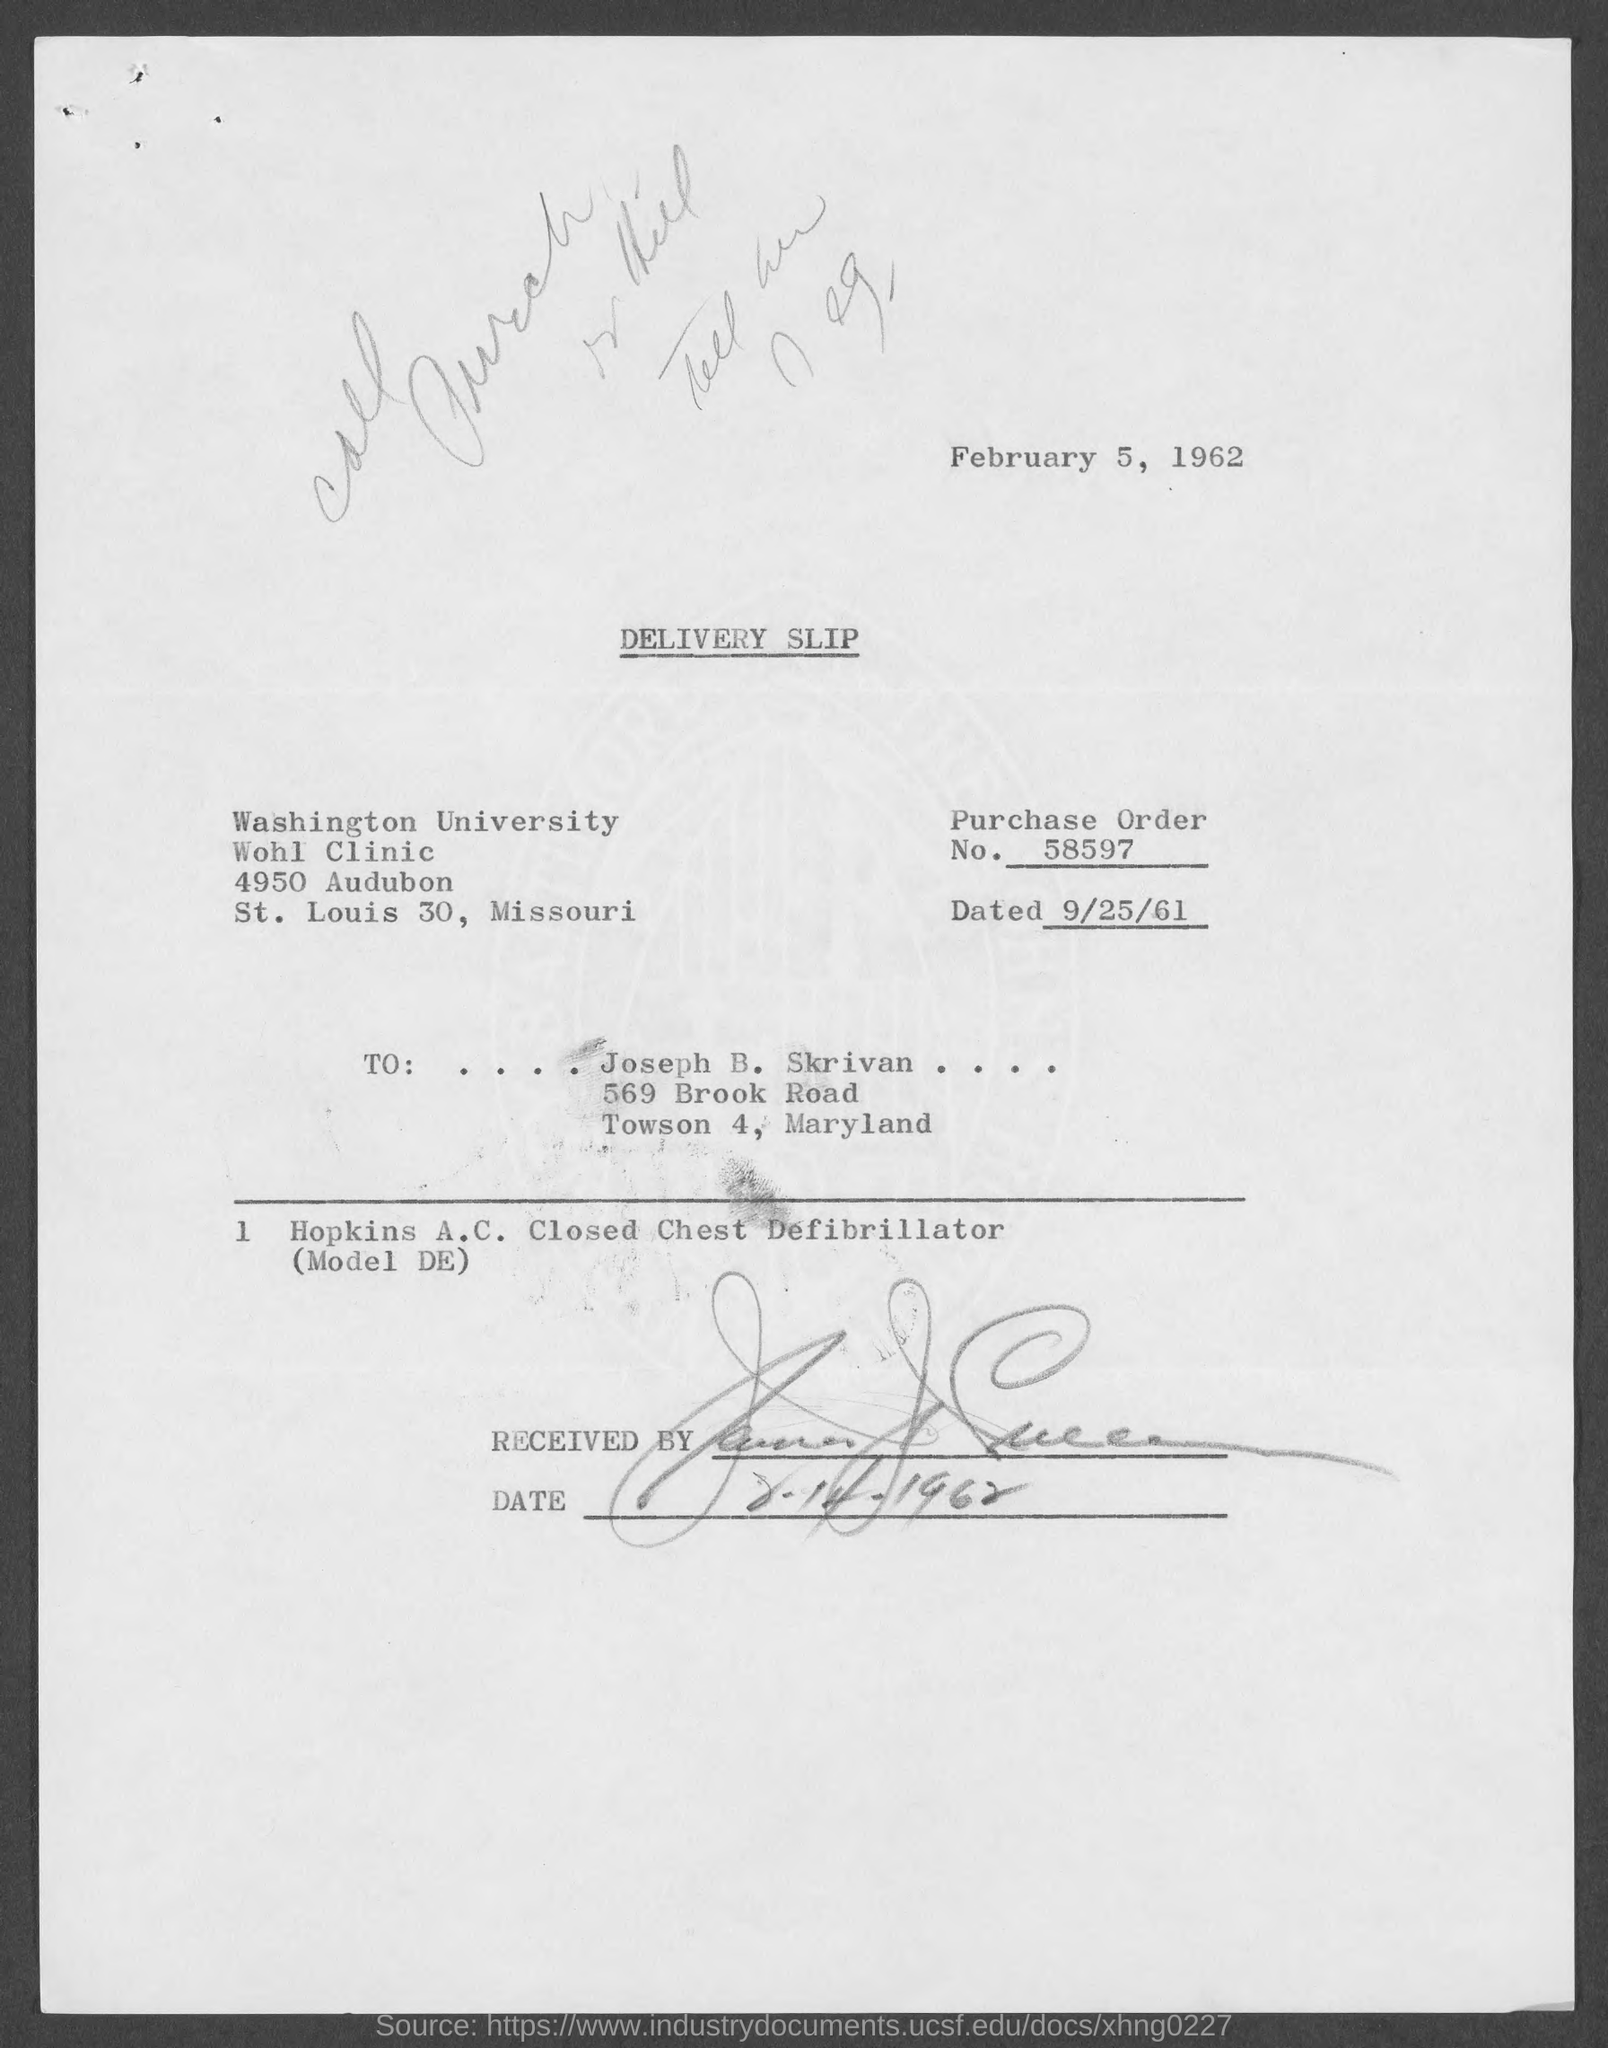What is the purchase order no. mentioned in the given page ?
Your response must be concise. 58597. What is the order dated on the slip as mentioned in the given page ?
Offer a very short reply. 9/25/61. What is the name of the university mentioned in the given form ?
Give a very brief answer. WASHINGTON UNIVERSITY. To whom the letter was sent ?
Your answer should be very brief. JOSEPH B. SKRIVAN. 